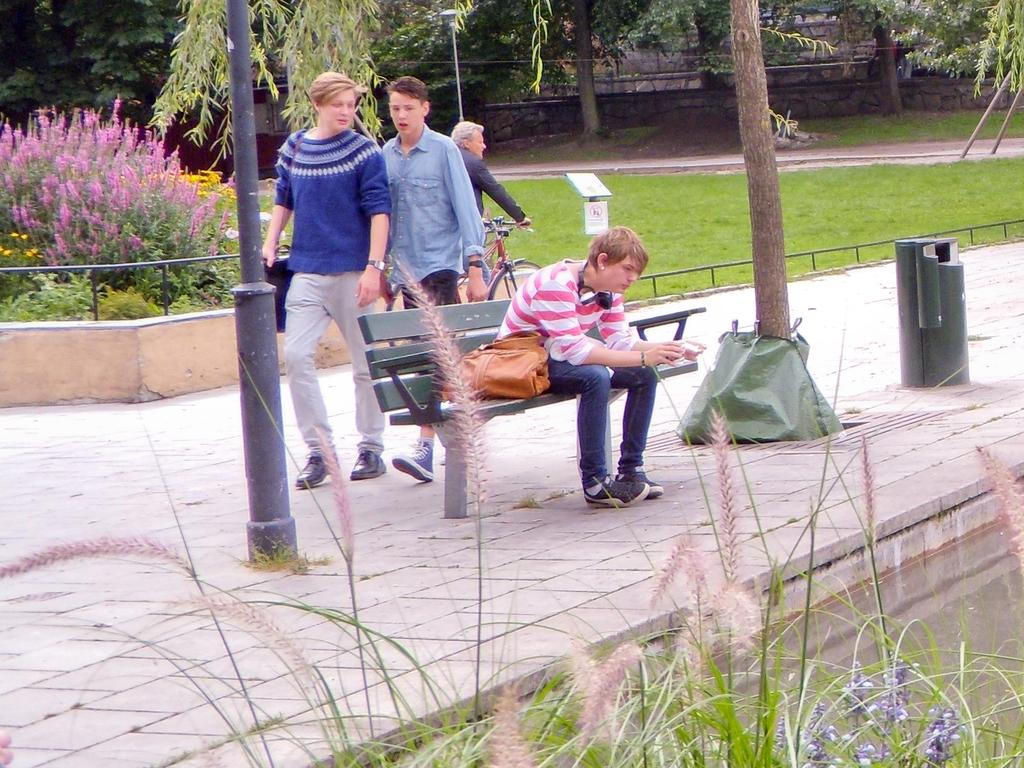What is the man in the image doing? The man is sitting on a bench in the image. What object is beside the man? There is a bag beside the man. How many people are standing in the background of the image? There are three people standing in the background of the image. What can be seen in the background of the image besides the people? There is a bicycle, a small plant, and a pole in the background of the image. What type of sticks are being used by the man to play a game in the image? There are no sticks or games present in the image; the man is simply sitting on a bench. 